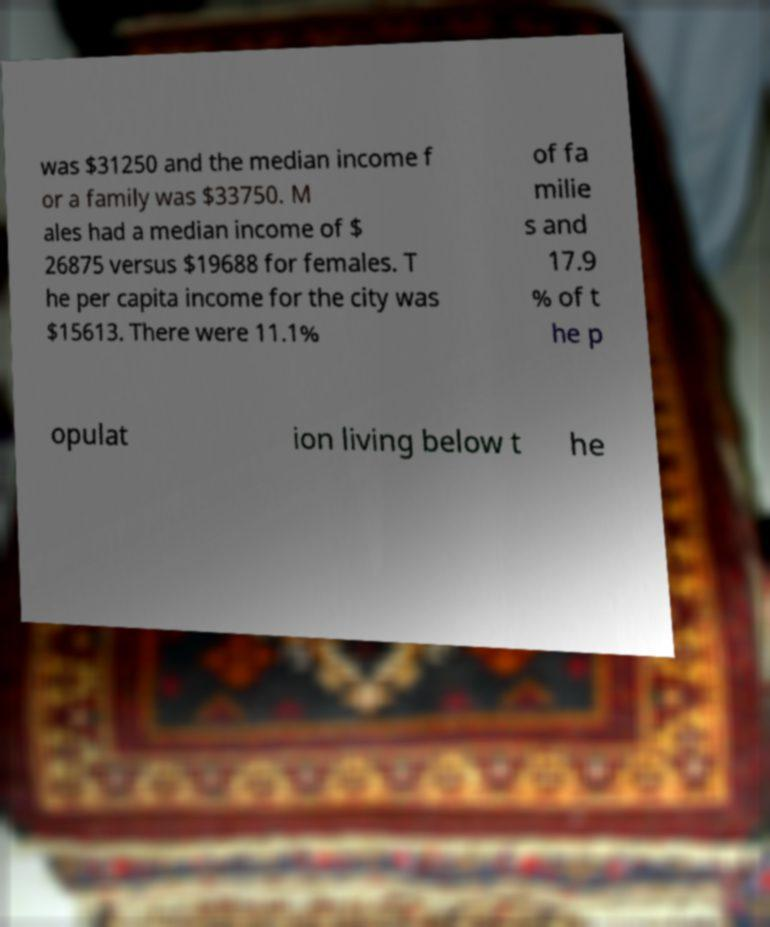Please read and relay the text visible in this image. What does it say? was $31250 and the median income f or a family was $33750. M ales had a median income of $ 26875 versus $19688 for females. T he per capita income for the city was $15613. There were 11.1% of fa milie s and 17.9 % of t he p opulat ion living below t he 